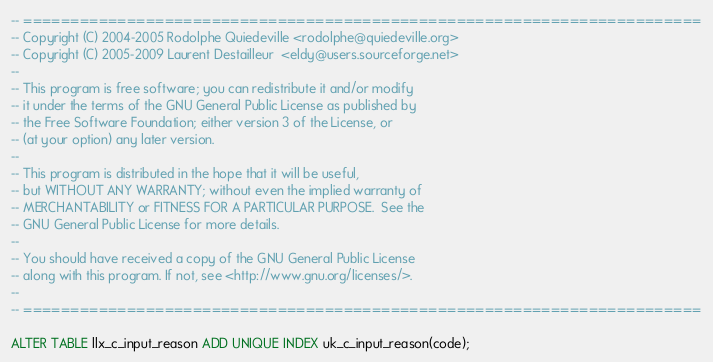Convert code to text. <code><loc_0><loc_0><loc_500><loc_500><_SQL_>-- ========================================================================
-- Copyright (C) 2004-2005 Rodolphe Quiedeville <rodolphe@quiedeville.org>
-- Copyright (C) 2005-2009 Laurent Destailleur  <eldy@users.sourceforge.net>
--
-- This program is free software; you can redistribute it and/or modify
-- it under the terms of the GNU General Public License as published by
-- the Free Software Foundation; either version 3 of the License, or
-- (at your option) any later version.
--
-- This program is distributed in the hope that it will be useful,
-- but WITHOUT ANY WARRANTY; without even the implied warranty of
-- MERCHANTABILITY or FITNESS FOR A PARTICULAR PURPOSE.  See the
-- GNU General Public License for more details.
--
-- You should have received a copy of the GNU General Public License
-- along with this program. If not, see <http://www.gnu.org/licenses/>.
--
-- ========================================================================

ALTER TABLE llx_c_input_reason ADD UNIQUE INDEX uk_c_input_reason(code);
</code> 